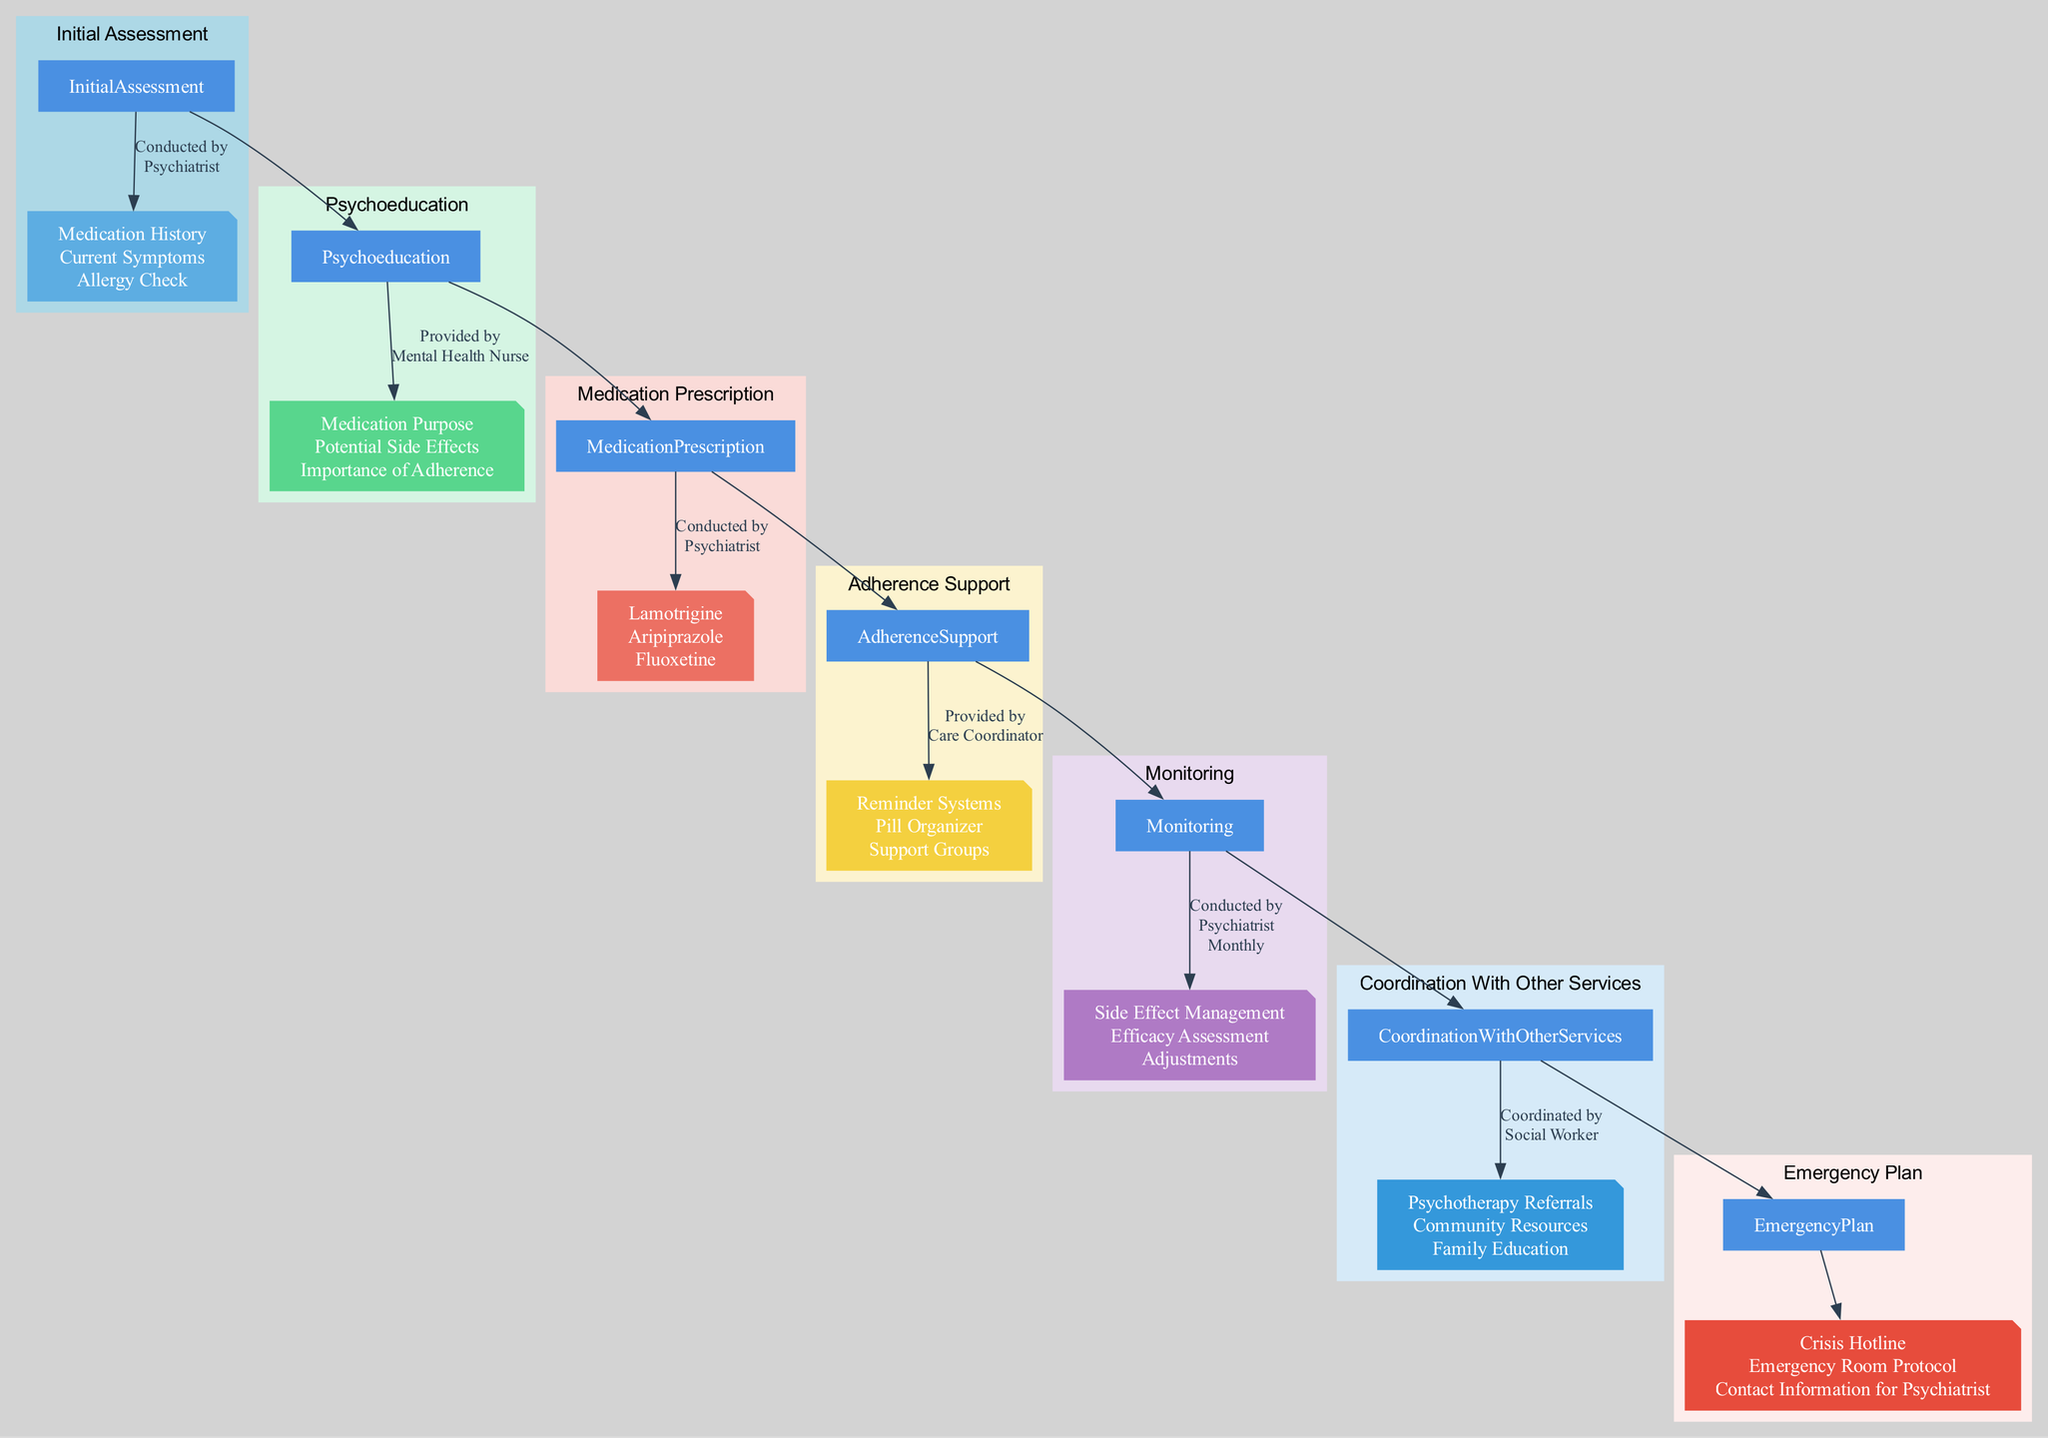What is the frequency of monitoring in the plan? The monitoring is scheduled to happen once a month, as indicated in the "Monitoring" section of the diagram.
Answer: Monthly Who conducts the initial assessment? The initial assessment is conducted by the psychiatrist, as shown by the label connecting "Initial Assessment" to "Psychiatrist."
Answer: Psychiatrist What additional support is provided by the Care Coordinator? The Care Coordinator provides adherence support including reminder systems, pill organizers, and support groups as specified in the "Adherence Support" section.
Answer: Reminder systems, Pill organizer, Support groups What components are included in the emergency plan? The emergency plan includes a crisis hotline, emergency room protocol, and contact information for the psychiatrist, as detailed in the "Emergency Plan" section.
Answer: Crisis hotline, Emergency Room Protocol, Contact Information for Psychiatrist Which professional is responsible for psychoeducation? Psychoeducation is provided by the mental health nurse, as indicated in the "Psychoeducation" section of the diagram.
Answer: Mental Health Nurse What are the medication examples prescribed in the plan? The medication examples listed are Lamotrigine, Aripiprazole, and Fluoxetine, found in the "Medication Prescription" section.
Answer: Lamotrigine, Aripiprazole, Fluoxetine How often are dosage adjustments made? Dosage adjustments are made bi-weekly, as indicated in the "Dosage Adjustment" part of the "Medication Prescription" section.
Answer: Bi-Weekly What is the role of the social worker in the plan? The social worker coordinates with other services, facilitating psychotherapy referrals, community resources, and family education, as shown in the "Coordination With Other Services" section.
Answer: Coordinated by Social Worker What is the relationship between psychoeducation and medication prescription? Psychoeducation is a prerequisite step before medication prescription; it flows from "Psychoeducation" to "Medication Prescription" in the pathway.
Answer: Flow relationship 